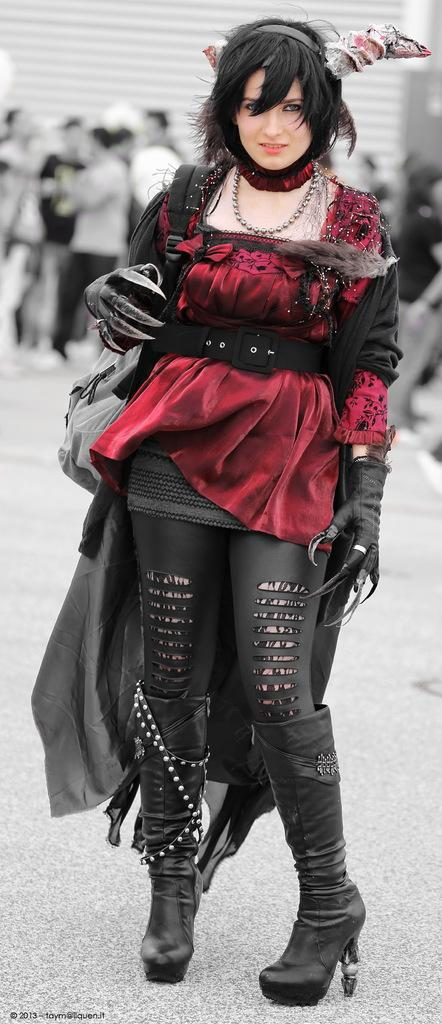Who is the main subject in the image? There is a woman in the image. What is the woman doing in the image? The woman is standing. Can you describe the woman's outfit in the image? The woman is wearing a maroon and black color dress, black boots, headwear, and a chain. Are there any other people visible in the image? Yes, there are people visible in the background of the image. What is the woman's opinion on water conservation in the image? There is no information about the woman's opinion on water conservation in the image. 